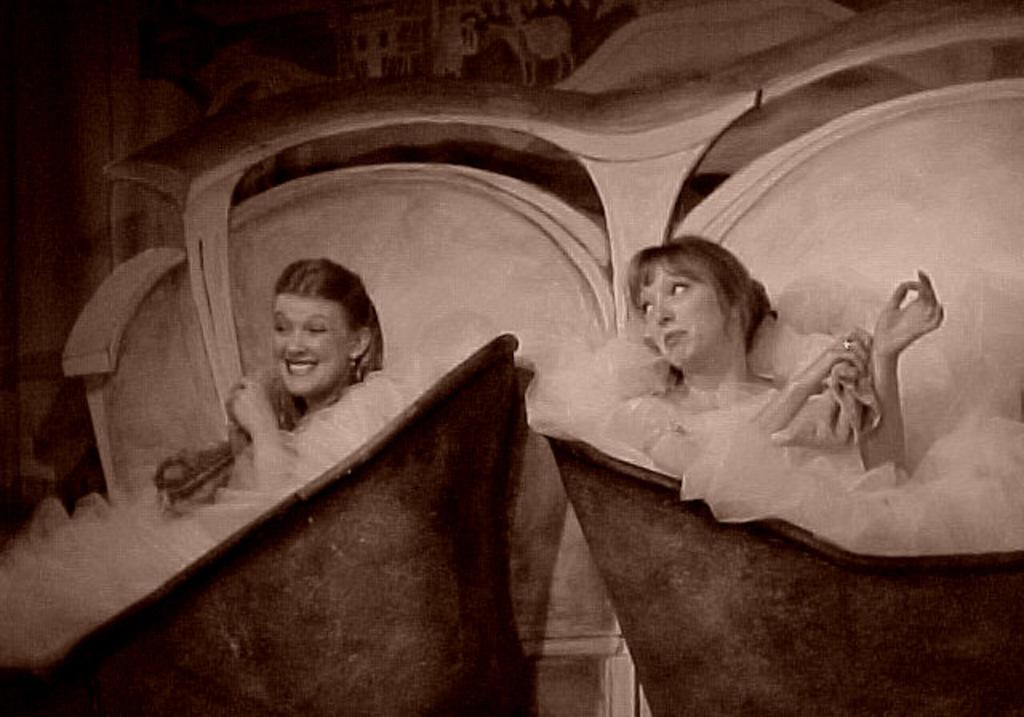How many people are in the image? There are two women in the image. What is the facial expression of the women in the image? Both women are smiling. What is the color scheme of the image? The image is black and white. What objects can be seen in the image? There are tubs in the image. What is visible in the background of the image? There is a wall in the background of the image. What is the tendency of the society depicted in the image? The image does not depict a society, so it is not possible to determine the tendency of the society. Where are the women going on vacation in the image? There is no indication of a vacation in the image, as it only shows two women smiling with tubs and a wall in the background. 